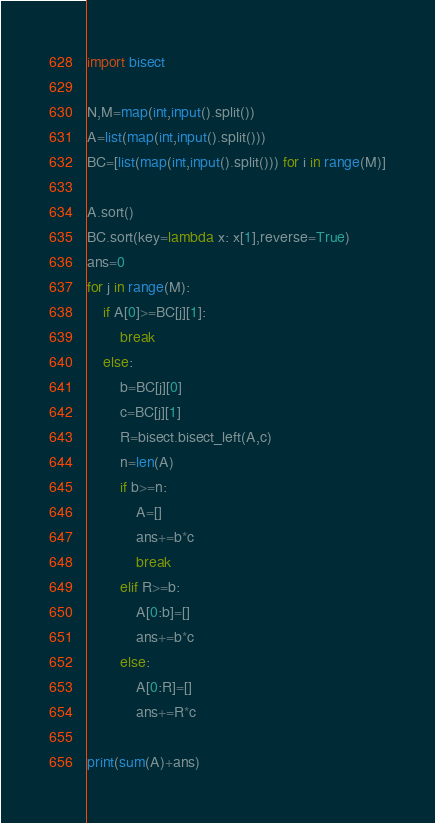Convert code to text. <code><loc_0><loc_0><loc_500><loc_500><_Python_>import bisect

N,M=map(int,input().split())
A=list(map(int,input().split()))
BC=[list(map(int,input().split())) for i in range(M)]

A.sort()
BC.sort(key=lambda x: x[1],reverse=True) 
ans=0
for j in range(M):
    if A[0]>=BC[j][1]:
        break
    else:
        b=BC[j][0]
        c=BC[j][1]
        R=bisect.bisect_left(A,c)
        n=len(A)
        if b>=n:
            A=[]
            ans+=b*c
            break
        elif R>=b:
            A[0:b]=[]
            ans+=b*c
        else:
            A[0:R]=[]
            ans+=R*c
        
print(sum(A)+ans)</code> 